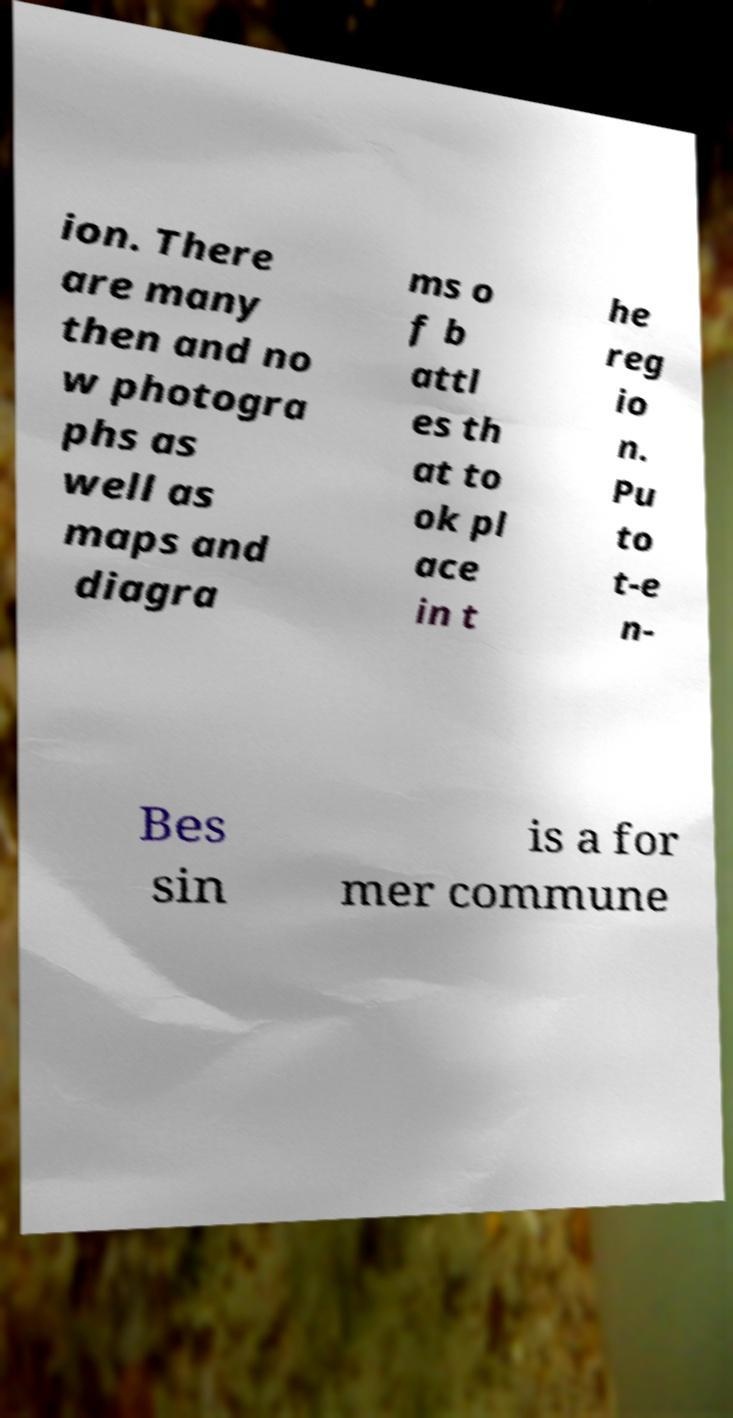Please identify and transcribe the text found in this image. ion. There are many then and no w photogra phs as well as maps and diagra ms o f b attl es th at to ok pl ace in t he reg io n. Pu to t-e n- Bes sin is a for mer commune 